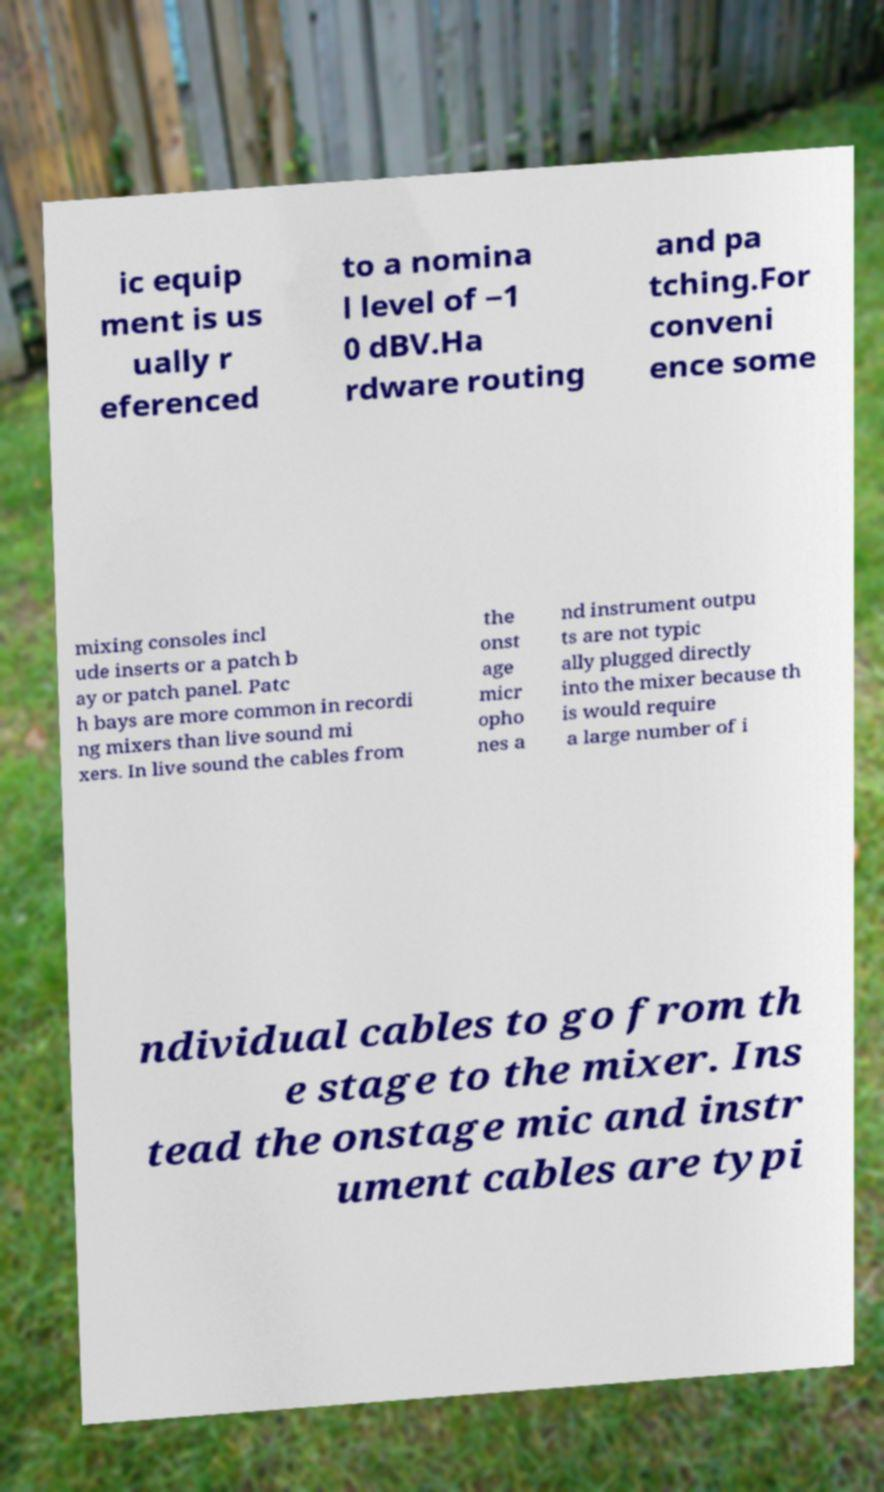Could you assist in decoding the text presented in this image and type it out clearly? ic equip ment is us ually r eferenced to a nomina l level of −1 0 dBV.Ha rdware routing and pa tching.For conveni ence some mixing consoles incl ude inserts or a patch b ay or patch panel. Patc h bays are more common in recordi ng mixers than live sound mi xers. In live sound the cables from the onst age micr opho nes a nd instrument outpu ts are not typic ally plugged directly into the mixer because th is would require a large number of i ndividual cables to go from th e stage to the mixer. Ins tead the onstage mic and instr ument cables are typi 